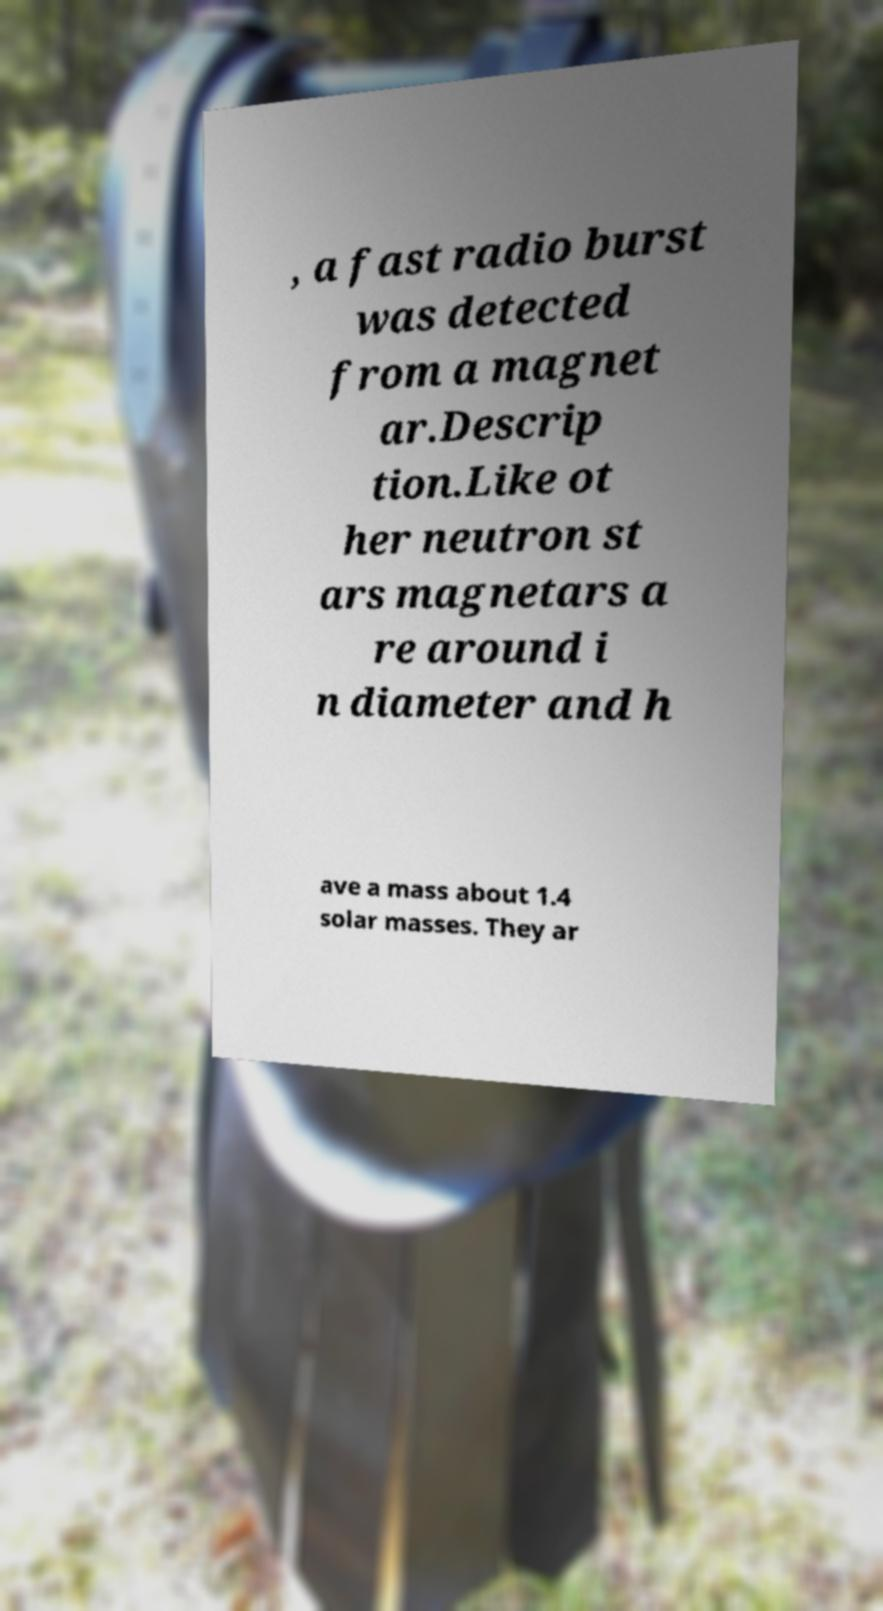Please read and relay the text visible in this image. What does it say? , a fast radio burst was detected from a magnet ar.Descrip tion.Like ot her neutron st ars magnetars a re around i n diameter and h ave a mass about 1.4 solar masses. They ar 